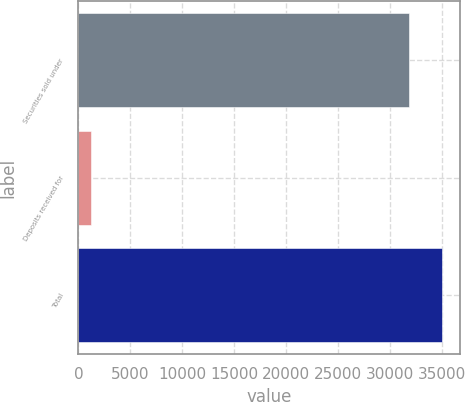Convert chart to OTSL. <chart><loc_0><loc_0><loc_500><loc_500><bar_chart><fcel>Securities sold under<fcel>Deposits received for<fcel>Total<nl><fcel>31831<fcel>1181<fcel>35014.1<nl></chart> 